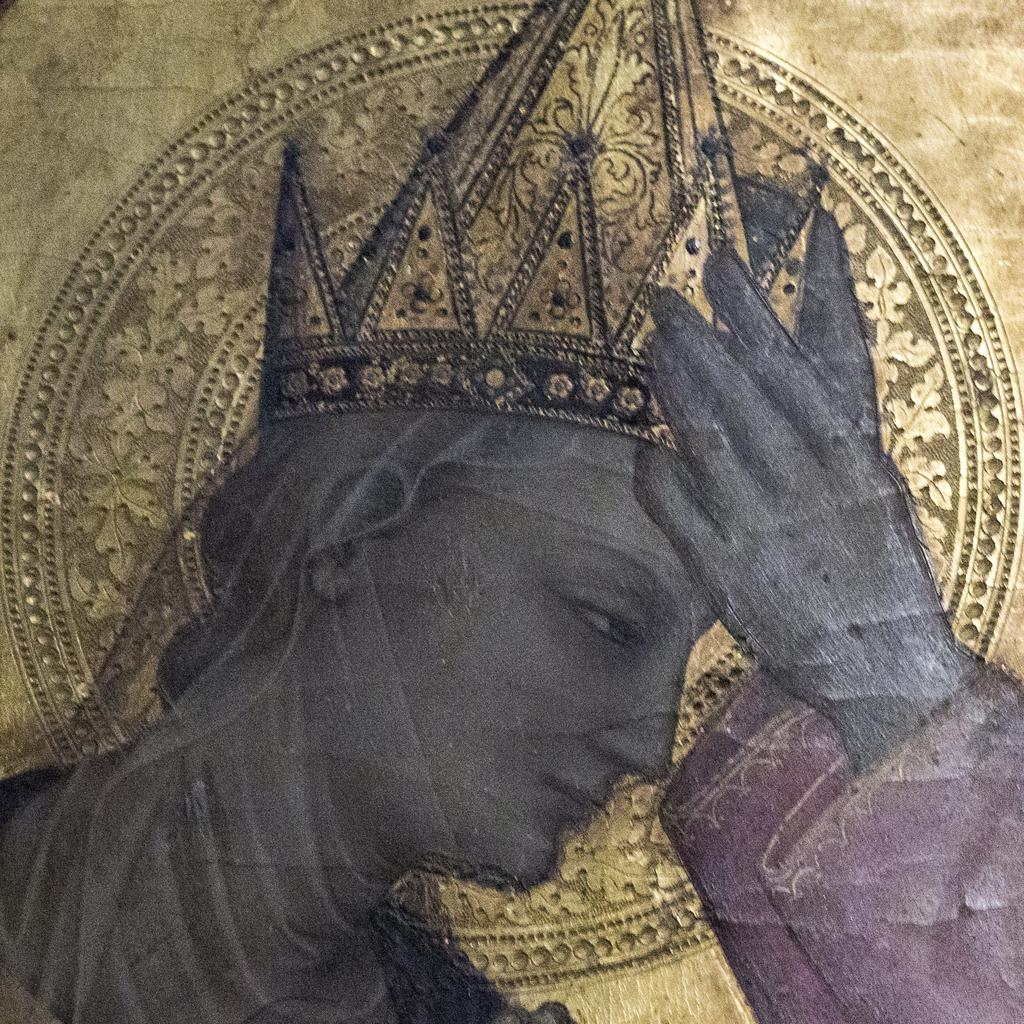What is the main subject of the image? There is a person in the image. What type of bone can be seen in the person's hand in the image? There is no bone visible in the person's hand in the image. What kind of cracker is the person eating in the image? There is no cracker present in the image. 